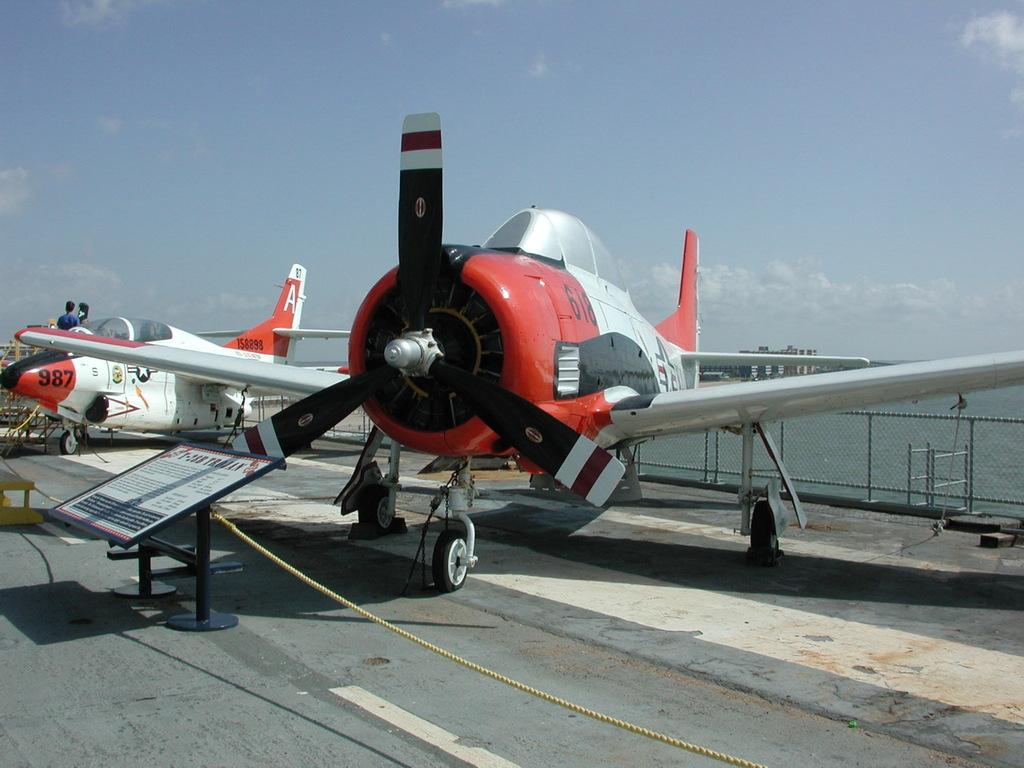<image>
Relay a brief, clear account of the picture shown. Two prop planes, the furthest away one says 987 on the nose. 